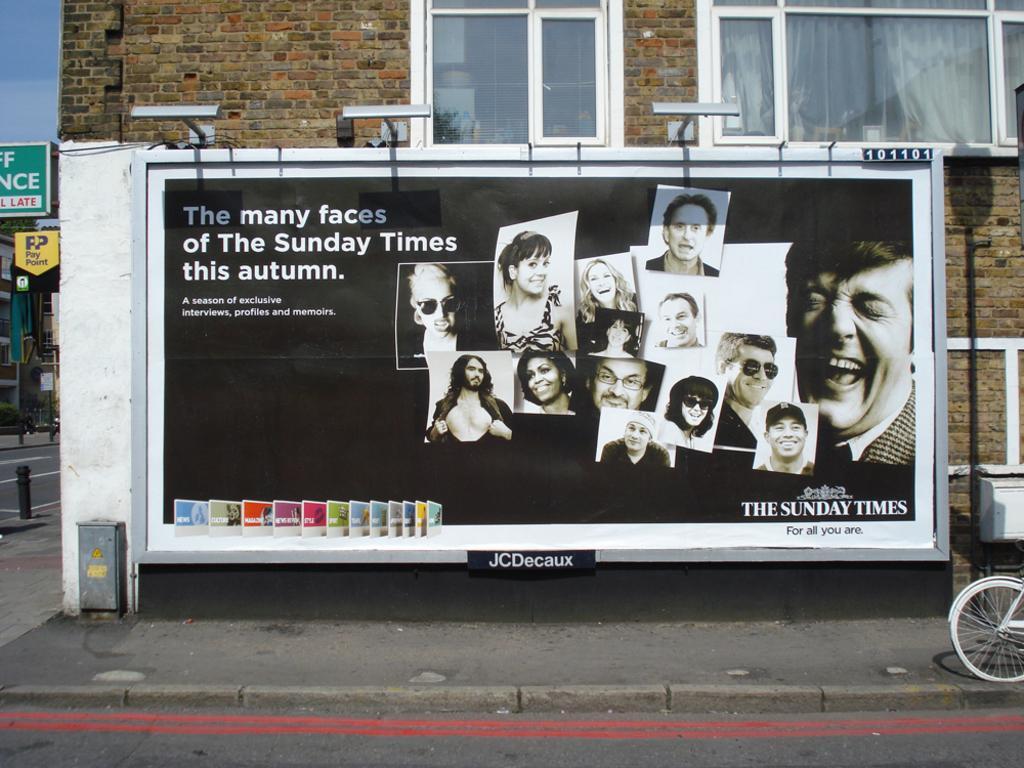Describe this image in one or two sentences. In this image there is a building with advertising banner in front of that, at the right side bottom there is a wheel of the bicycle, at the left side there are so many other things. 